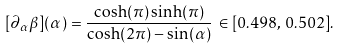Convert formula to latex. <formula><loc_0><loc_0><loc_500><loc_500>[ \partial _ { \alpha } \beta ] ( \alpha ) = \frac { \cosh ( \pi ) \sinh ( \pi ) } { \cosh ( 2 \pi ) - \sin ( \alpha ) } \, \in [ 0 . 4 9 8 , \, 0 . 5 0 2 ] .</formula> 